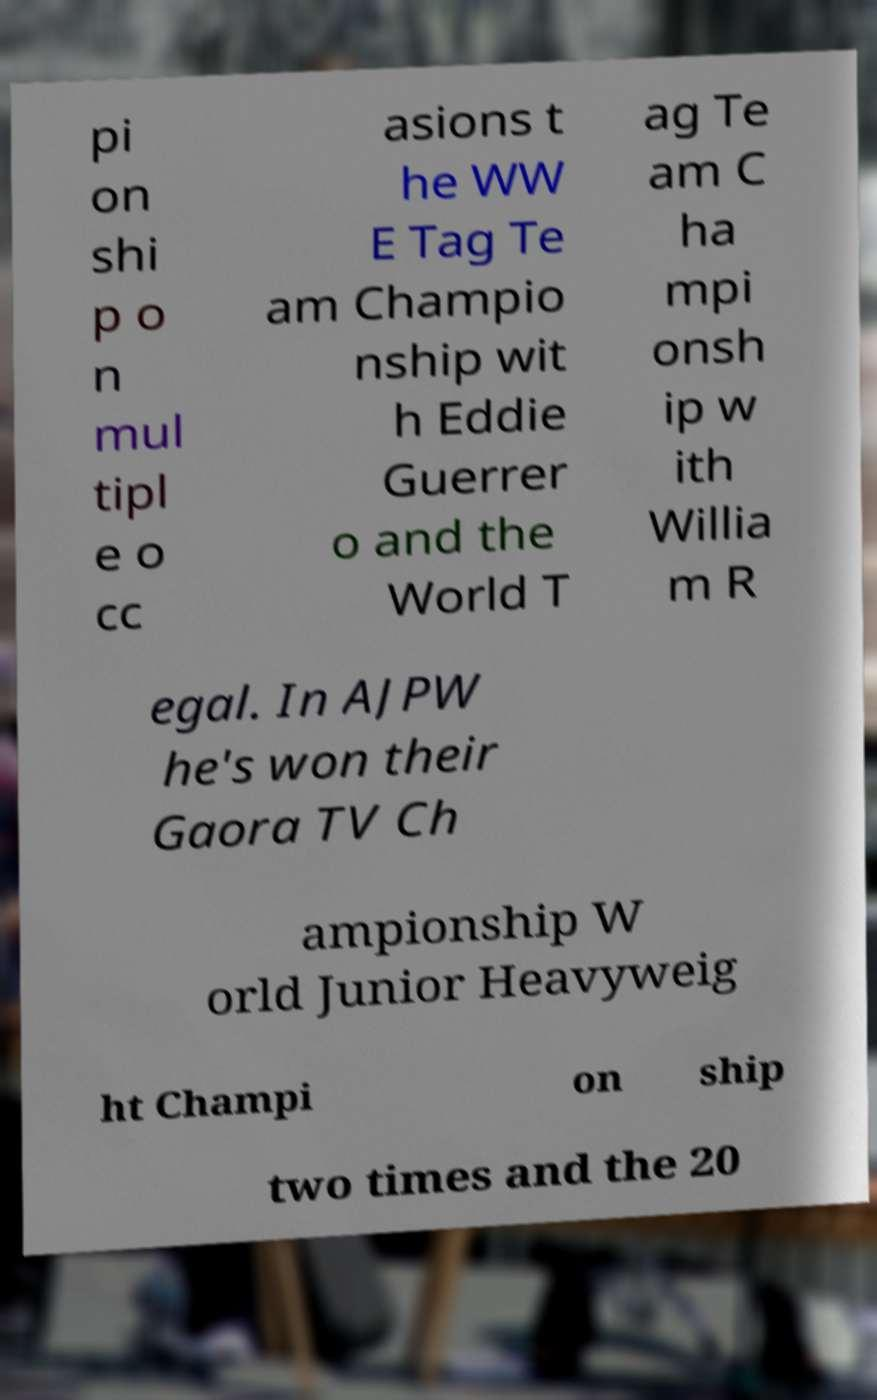Can you read and provide the text displayed in the image?This photo seems to have some interesting text. Can you extract and type it out for me? pi on shi p o n mul tipl e o cc asions t he WW E Tag Te am Champio nship wit h Eddie Guerrer o and the World T ag Te am C ha mpi onsh ip w ith Willia m R egal. In AJPW he's won their Gaora TV Ch ampionship W orld Junior Heavyweig ht Champi on ship two times and the 20 